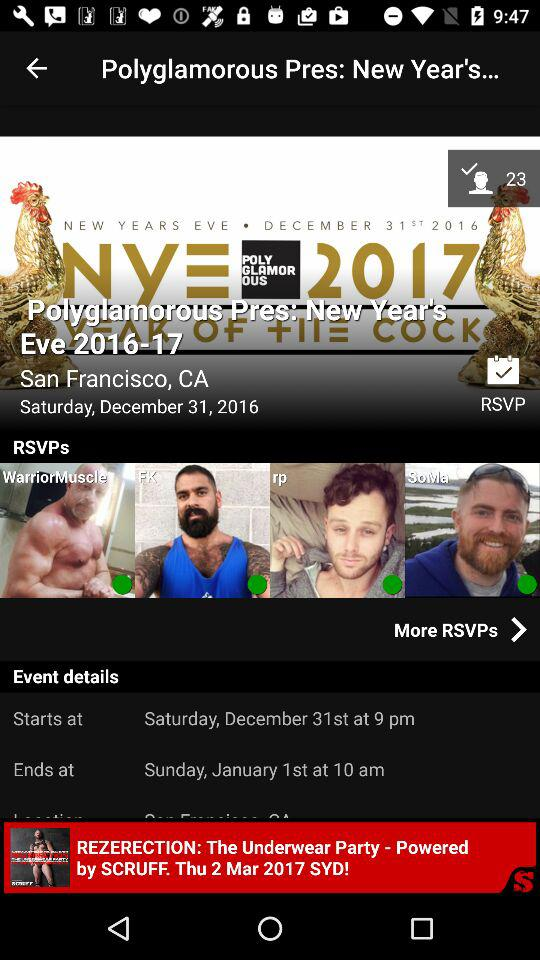What is the date of the "Polyglamorous Pres: New Year's Eve"? The date of the "Polyglamorous Pres: New Year's Eve" is Saturday, December 31, 2016. 